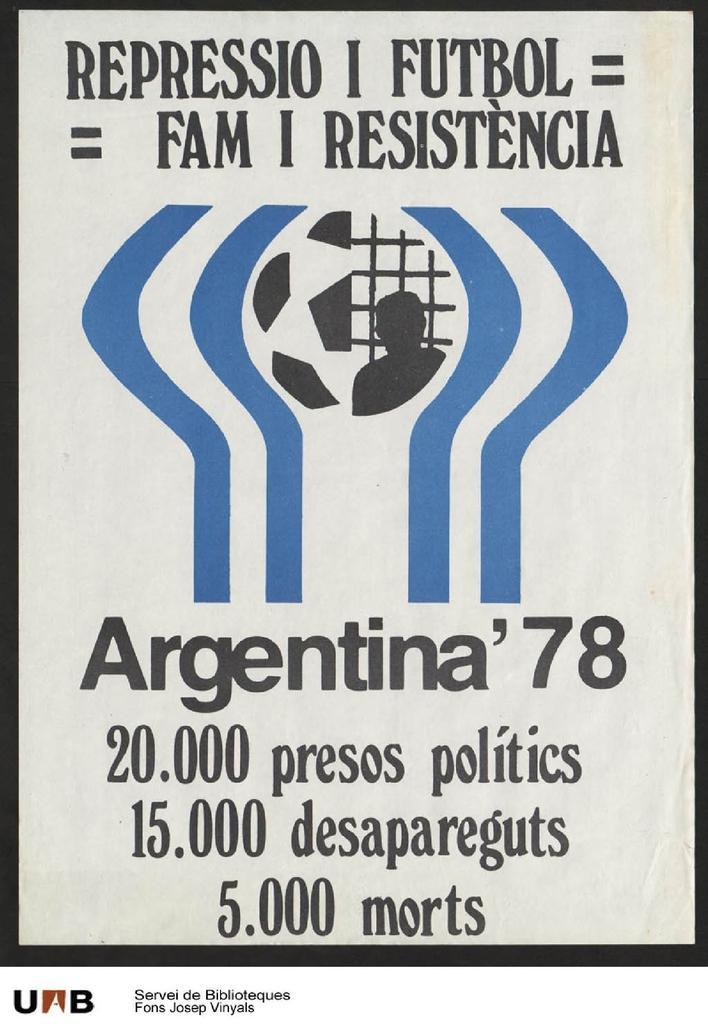Can you describe this image briefly? This picture contains a poster. We see some text written on the poster in black color. In the background, it is white in color. 